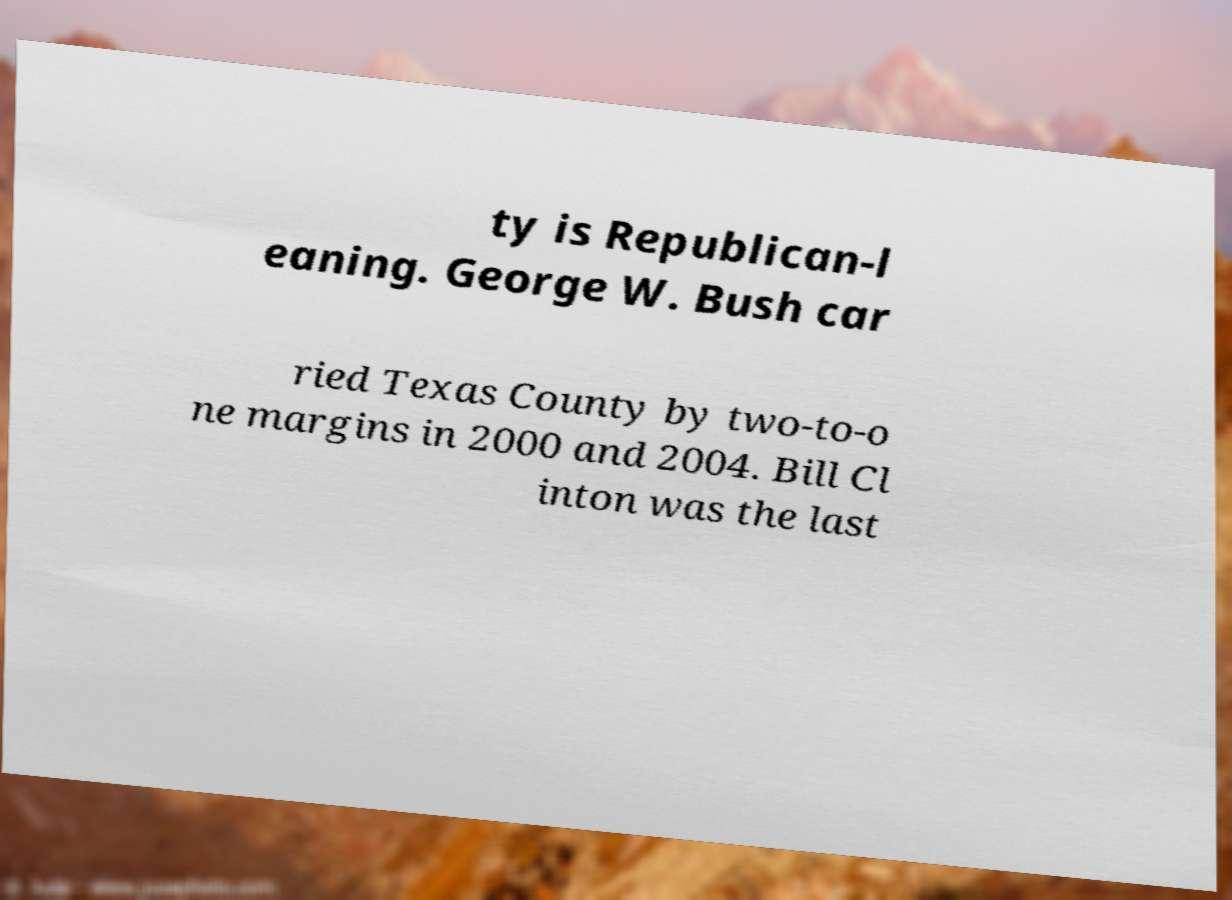Please read and relay the text visible in this image. What does it say? ty is Republican-l eaning. George W. Bush car ried Texas County by two-to-o ne margins in 2000 and 2004. Bill Cl inton was the last 